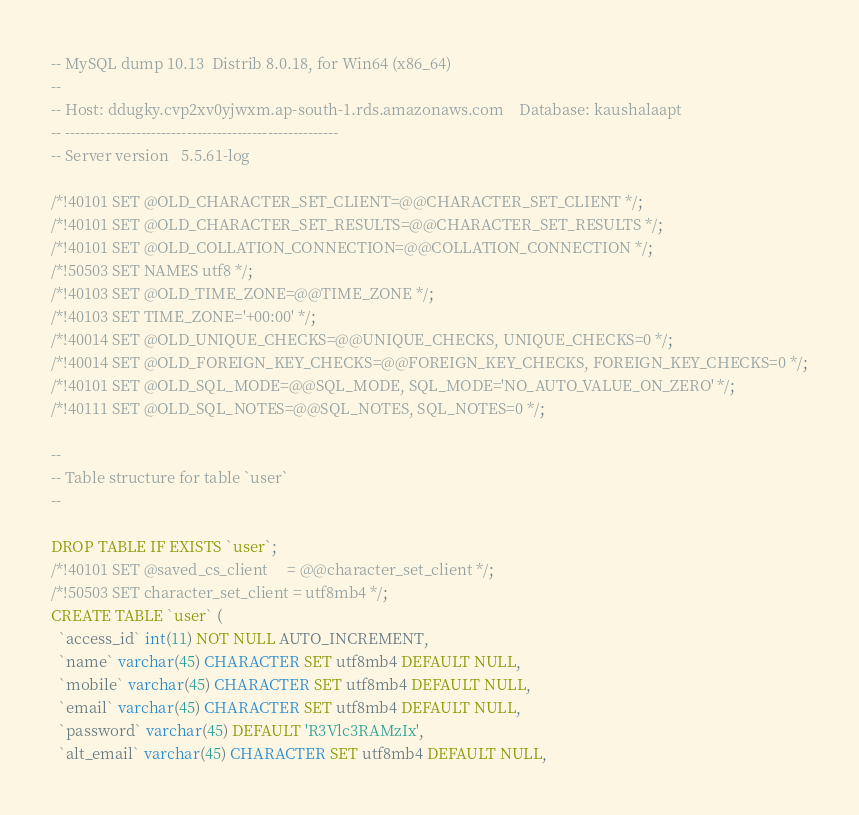Convert code to text. <code><loc_0><loc_0><loc_500><loc_500><_SQL_>-- MySQL dump 10.13  Distrib 8.0.18, for Win64 (x86_64)
--
-- Host: ddugky.cvp2xv0yjwxm.ap-south-1.rds.amazonaws.com    Database: kaushalaapt
-- ------------------------------------------------------
-- Server version	5.5.61-log

/*!40101 SET @OLD_CHARACTER_SET_CLIENT=@@CHARACTER_SET_CLIENT */;
/*!40101 SET @OLD_CHARACTER_SET_RESULTS=@@CHARACTER_SET_RESULTS */;
/*!40101 SET @OLD_COLLATION_CONNECTION=@@COLLATION_CONNECTION */;
/*!50503 SET NAMES utf8 */;
/*!40103 SET @OLD_TIME_ZONE=@@TIME_ZONE */;
/*!40103 SET TIME_ZONE='+00:00' */;
/*!40014 SET @OLD_UNIQUE_CHECKS=@@UNIQUE_CHECKS, UNIQUE_CHECKS=0 */;
/*!40014 SET @OLD_FOREIGN_KEY_CHECKS=@@FOREIGN_KEY_CHECKS, FOREIGN_KEY_CHECKS=0 */;
/*!40101 SET @OLD_SQL_MODE=@@SQL_MODE, SQL_MODE='NO_AUTO_VALUE_ON_ZERO' */;
/*!40111 SET @OLD_SQL_NOTES=@@SQL_NOTES, SQL_NOTES=0 */;

--
-- Table structure for table `user`
--

DROP TABLE IF EXISTS `user`;
/*!40101 SET @saved_cs_client     = @@character_set_client */;
/*!50503 SET character_set_client = utf8mb4 */;
CREATE TABLE `user` (
  `access_id` int(11) NOT NULL AUTO_INCREMENT,
  `name` varchar(45) CHARACTER SET utf8mb4 DEFAULT NULL,
  `mobile` varchar(45) CHARACTER SET utf8mb4 DEFAULT NULL,
  `email` varchar(45) CHARACTER SET utf8mb4 DEFAULT NULL,
  `password` varchar(45) DEFAULT 'R3Vlc3RAMzIx',
  `alt_email` varchar(45) CHARACTER SET utf8mb4 DEFAULT NULL,</code> 